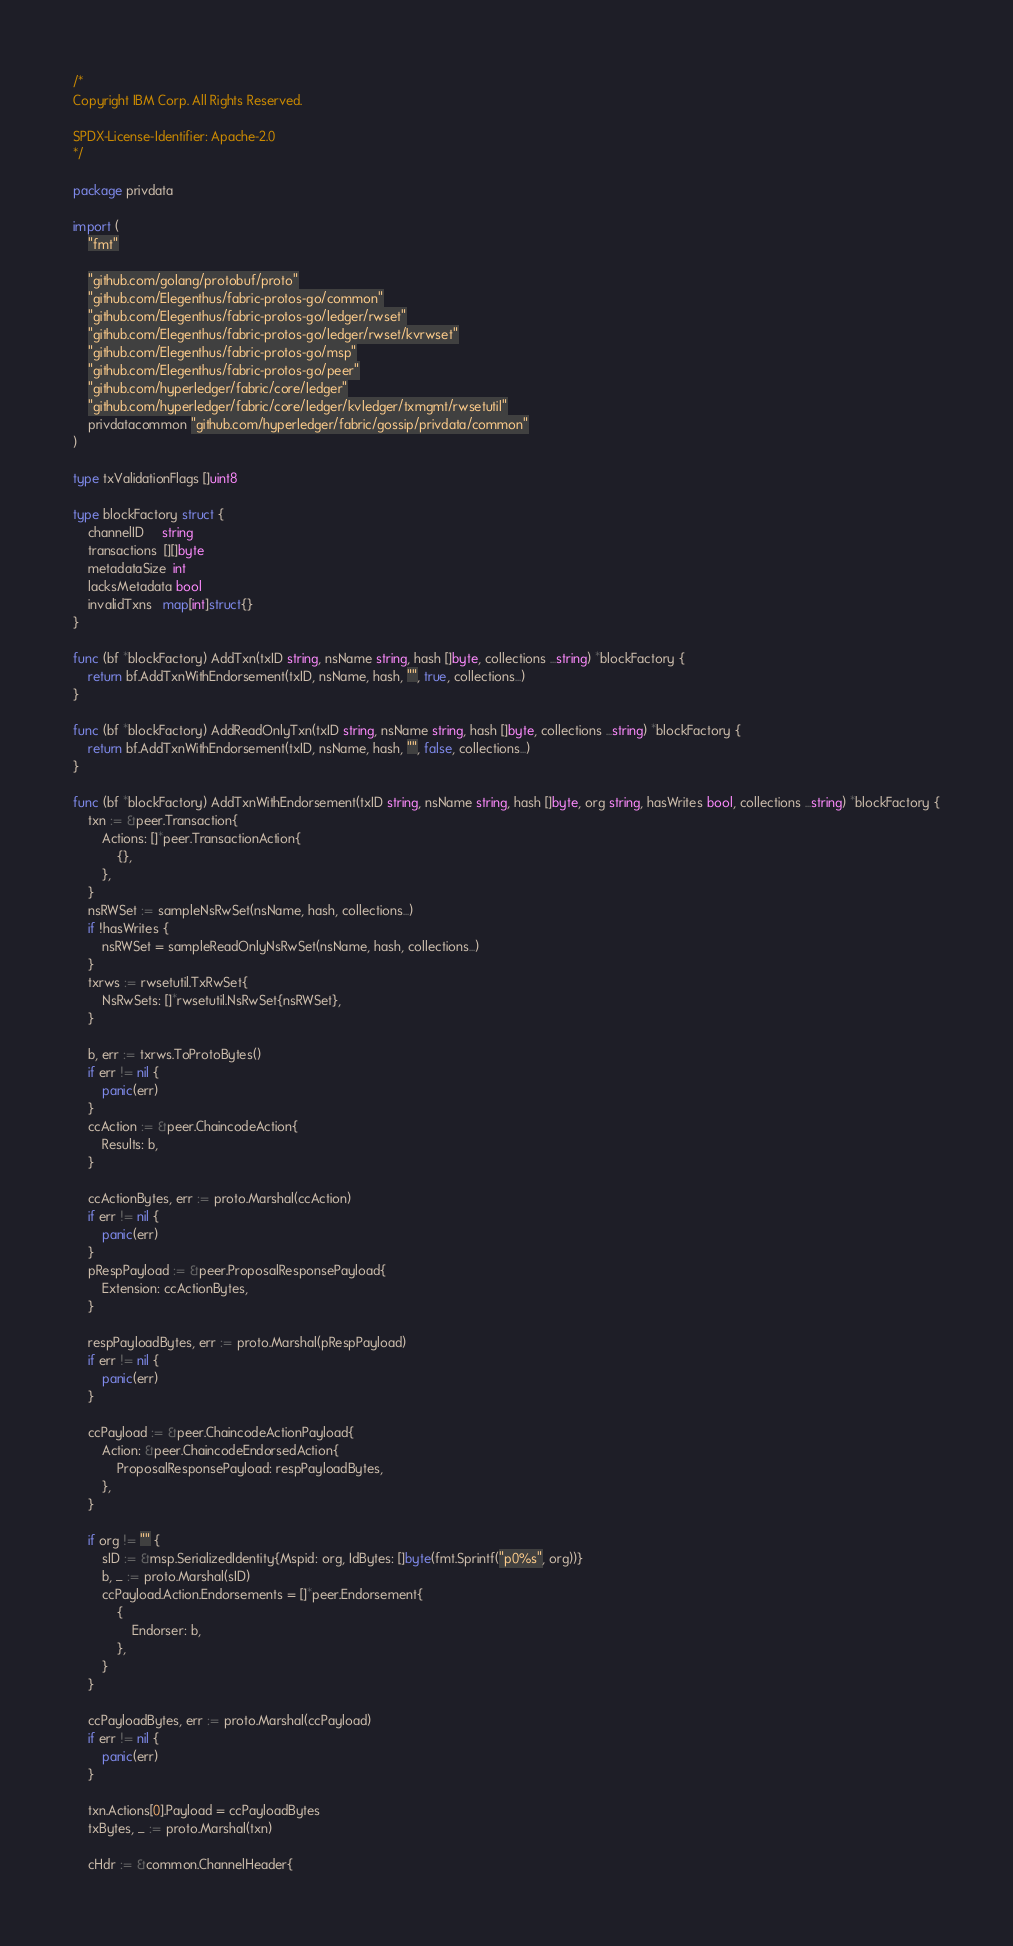Convert code to text. <code><loc_0><loc_0><loc_500><loc_500><_Go_>/*
Copyright IBM Corp. All Rights Reserved.

SPDX-License-Identifier: Apache-2.0
*/

package privdata

import (
	"fmt"

	"github.com/golang/protobuf/proto"
	"github.com/Elegenthus/fabric-protos-go/common"
	"github.com/Elegenthus/fabric-protos-go/ledger/rwset"
	"github.com/Elegenthus/fabric-protos-go/ledger/rwset/kvrwset"
	"github.com/Elegenthus/fabric-protos-go/msp"
	"github.com/Elegenthus/fabric-protos-go/peer"
	"github.com/hyperledger/fabric/core/ledger"
	"github.com/hyperledger/fabric/core/ledger/kvledger/txmgmt/rwsetutil"
	privdatacommon "github.com/hyperledger/fabric/gossip/privdata/common"
)

type txValidationFlags []uint8

type blockFactory struct {
	channelID     string
	transactions  [][]byte
	metadataSize  int
	lacksMetadata bool
	invalidTxns   map[int]struct{}
}

func (bf *blockFactory) AddTxn(txID string, nsName string, hash []byte, collections ...string) *blockFactory {
	return bf.AddTxnWithEndorsement(txID, nsName, hash, "", true, collections...)
}

func (bf *blockFactory) AddReadOnlyTxn(txID string, nsName string, hash []byte, collections ...string) *blockFactory {
	return bf.AddTxnWithEndorsement(txID, nsName, hash, "", false, collections...)
}

func (bf *blockFactory) AddTxnWithEndorsement(txID string, nsName string, hash []byte, org string, hasWrites bool, collections ...string) *blockFactory {
	txn := &peer.Transaction{
		Actions: []*peer.TransactionAction{
			{},
		},
	}
	nsRWSet := sampleNsRwSet(nsName, hash, collections...)
	if !hasWrites {
		nsRWSet = sampleReadOnlyNsRwSet(nsName, hash, collections...)
	}
	txrws := rwsetutil.TxRwSet{
		NsRwSets: []*rwsetutil.NsRwSet{nsRWSet},
	}

	b, err := txrws.ToProtoBytes()
	if err != nil {
		panic(err)
	}
	ccAction := &peer.ChaincodeAction{
		Results: b,
	}

	ccActionBytes, err := proto.Marshal(ccAction)
	if err != nil {
		panic(err)
	}
	pRespPayload := &peer.ProposalResponsePayload{
		Extension: ccActionBytes,
	}

	respPayloadBytes, err := proto.Marshal(pRespPayload)
	if err != nil {
		panic(err)
	}

	ccPayload := &peer.ChaincodeActionPayload{
		Action: &peer.ChaincodeEndorsedAction{
			ProposalResponsePayload: respPayloadBytes,
		},
	}

	if org != "" {
		sID := &msp.SerializedIdentity{Mspid: org, IdBytes: []byte(fmt.Sprintf("p0%s", org))}
		b, _ := proto.Marshal(sID)
		ccPayload.Action.Endorsements = []*peer.Endorsement{
			{
				Endorser: b,
			},
		}
	}

	ccPayloadBytes, err := proto.Marshal(ccPayload)
	if err != nil {
		panic(err)
	}

	txn.Actions[0].Payload = ccPayloadBytes
	txBytes, _ := proto.Marshal(txn)

	cHdr := &common.ChannelHeader{</code> 